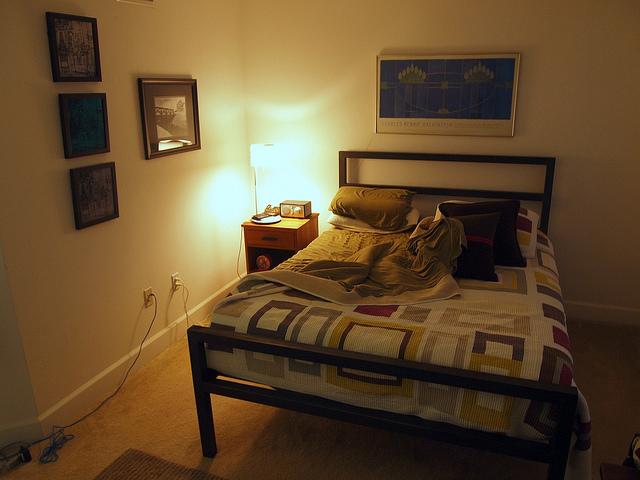Where are the picture frames?
Answer briefly. On wall. What pictures are on the wall?
Concise answer only. Paintings. How many people are sleeping on the bed?
Give a very brief answer. 0. Is this a juvenile's room?
Keep it brief. No. Is this an adult's bed or a child's bed?
Be succinct. Adult. How many beds are in the room?
Write a very short answer. 1. What is laying in the bed?
Quick response, please. Blanket. What is on the bed stand?
Be succinct. Light. What is the title on the framed picture?
Short answer required. Frame on wall. What non-fish organisms adorn the beds?
Give a very brief answer. None. 